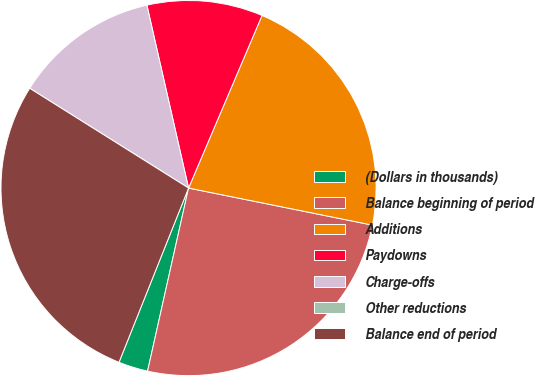<chart> <loc_0><loc_0><loc_500><loc_500><pie_chart><fcel>(Dollars in thousands)<fcel>Balance beginning of period<fcel>Additions<fcel>Paydowns<fcel>Charge-offs<fcel>Other reductions<fcel>Balance end of period<nl><fcel>2.54%<fcel>25.34%<fcel>21.76%<fcel>9.97%<fcel>12.51%<fcel>0.0%<fcel>27.88%<nl></chart> 